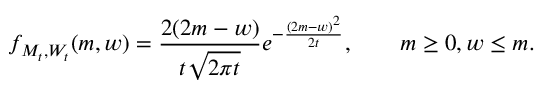Convert formula to latex. <formula><loc_0><loc_0><loc_500><loc_500>f _ { M _ { t } , W _ { t } } ( m , w ) = { \frac { 2 ( 2 m - w ) } { t { \sqrt { 2 \pi t } } } } e ^ { - { \frac { ( 2 m - w ) ^ { 2 } } { 2 t } } } , \quad m \geq 0 , w \leq m .</formula> 